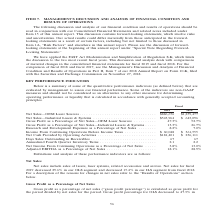According to Coherent's financial document, What does the table show? a summary of some of the quantitative performance indicators (as defined below) that are evaluated by management to assess our financial performance.. The document states: "Below is a summary of some of the quantitative performance indicators (as defined below) that are evaluated by management to assess our financial perf..." Also, What is the amount of net sales for OEM Laser Sources in 2019? According to the financial document, $886,676. The relevant text states: "Net Sales—OEM Laser Sources . $886,676 $1,259,477 Net Sales—Industrial Lasers & Systems . $543,964 $ 643,096 Gross Profit as a Percentage o..." Also, In which years are the key performance indicators provided in the table? The document shows two values: 2019 and 2018. From the document: "the consolidated financial statements for fiscal 2019 and fiscal 2018. For the comparison of fiscal 2018 and fiscal 2017, see the Management’s Discuss..." Additionally, In which year was Research and Development Expenses as a Percentage of Net Sales larger? According to the financial document, 2019. The relevant text states: "the consolidated financial statements for fiscal 2019 and fiscal 2018. For the comparison of fiscal 2018 and fiscal 2017, see the Management’s Discussion..." Also, can you calculate: What was the change in Annualized Fourth Quarter Inventory Turns in 2019 from 2018? Based on the calculation: 2.1-2.2, the result is -0.1. This is based on the information: "7 Annualized Fourth Quarter Inventory Turns . 2.1 2.2 Net Income From Continuing Operations as a Percentage of Net Sales . 3.8% 13.0% Adjusted EBITDA as 67 67 Annualized Fourth Quarter Inventory Turns..." The key data points involved are: 2.1, 2.2. Also, can you calculate: What was the percentage change in Annualized Fourth Quarter Inventory Turns in 2019 from 2018? To answer this question, I need to perform calculations using the financial data. The calculation is: (2.1-2.2)/2.2, which equals -4.55 (percentage). This is based on the information: "7 Annualized Fourth Quarter Inventory Turns . 2.1 2.2 Net Income From Continuing Operations as a Percentage of Net Sales . 3.8% 13.0% Adjusted EBITDA as 67 67 Annualized Fourth Quarter Inventory Turns..." The key data points involved are: 2.1, 2.2. 